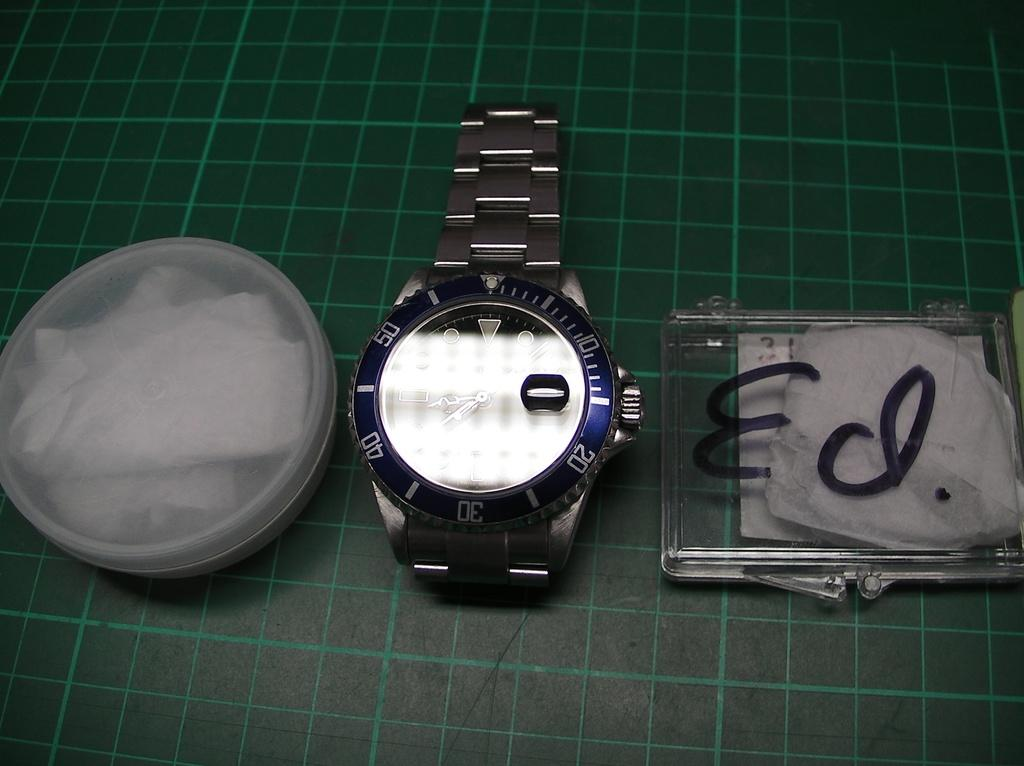<image>
Offer a succinct explanation of the picture presented. A watch is sitting between a round container and a square contained with Ed written on it in marker. 